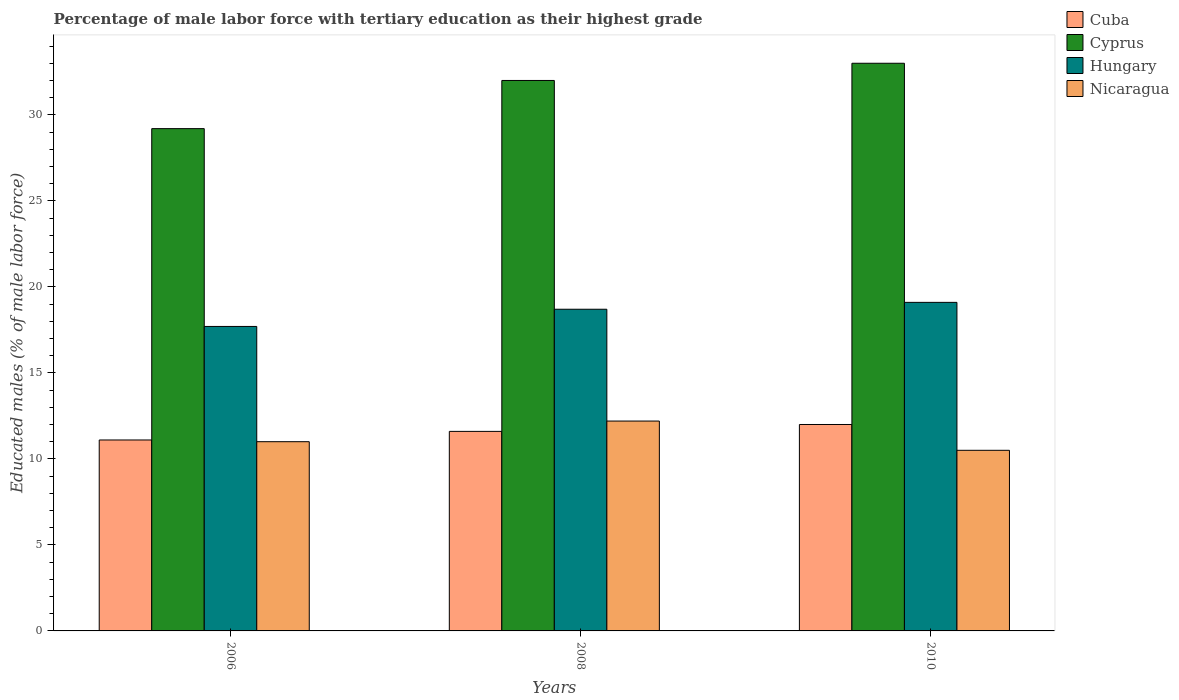Are the number of bars per tick equal to the number of legend labels?
Ensure brevity in your answer.  Yes. Are the number of bars on each tick of the X-axis equal?
Offer a terse response. Yes. How many bars are there on the 2nd tick from the right?
Your answer should be very brief. 4. Across all years, what is the maximum percentage of male labor force with tertiary education in Nicaragua?
Your answer should be very brief. 12.2. Across all years, what is the minimum percentage of male labor force with tertiary education in Cyprus?
Provide a succinct answer. 29.2. In which year was the percentage of male labor force with tertiary education in Cyprus maximum?
Your response must be concise. 2010. What is the total percentage of male labor force with tertiary education in Cuba in the graph?
Provide a succinct answer. 34.7. What is the difference between the percentage of male labor force with tertiary education in Cyprus in 2006 and that in 2008?
Offer a terse response. -2.8. What is the difference between the percentage of male labor force with tertiary education in Nicaragua in 2010 and the percentage of male labor force with tertiary education in Cuba in 2006?
Provide a succinct answer. -0.6. What is the average percentage of male labor force with tertiary education in Cyprus per year?
Your answer should be compact. 31.4. In the year 2010, what is the difference between the percentage of male labor force with tertiary education in Hungary and percentage of male labor force with tertiary education in Cyprus?
Make the answer very short. -13.9. What is the ratio of the percentage of male labor force with tertiary education in Hungary in 2006 to that in 2008?
Give a very brief answer. 0.95. Is the percentage of male labor force with tertiary education in Cyprus in 2008 less than that in 2010?
Provide a succinct answer. Yes. What is the difference between the highest and the second highest percentage of male labor force with tertiary education in Nicaragua?
Ensure brevity in your answer.  1.2. What is the difference between the highest and the lowest percentage of male labor force with tertiary education in Nicaragua?
Provide a succinct answer. 1.7. Is it the case that in every year, the sum of the percentage of male labor force with tertiary education in Nicaragua and percentage of male labor force with tertiary education in Cyprus is greater than the sum of percentage of male labor force with tertiary education in Hungary and percentage of male labor force with tertiary education in Cuba?
Give a very brief answer. No. What does the 2nd bar from the left in 2008 represents?
Make the answer very short. Cyprus. What does the 1st bar from the right in 2008 represents?
Offer a very short reply. Nicaragua. Is it the case that in every year, the sum of the percentage of male labor force with tertiary education in Cyprus and percentage of male labor force with tertiary education in Hungary is greater than the percentage of male labor force with tertiary education in Nicaragua?
Offer a terse response. Yes. What is the difference between two consecutive major ticks on the Y-axis?
Ensure brevity in your answer.  5. Are the values on the major ticks of Y-axis written in scientific E-notation?
Keep it short and to the point. No. Does the graph contain any zero values?
Provide a short and direct response. No. Does the graph contain grids?
Your answer should be compact. No. Where does the legend appear in the graph?
Offer a terse response. Top right. How many legend labels are there?
Keep it short and to the point. 4. What is the title of the graph?
Your answer should be compact. Percentage of male labor force with tertiary education as their highest grade. Does "Montenegro" appear as one of the legend labels in the graph?
Offer a very short reply. No. What is the label or title of the X-axis?
Offer a very short reply. Years. What is the label or title of the Y-axis?
Offer a terse response. Educated males (% of male labor force). What is the Educated males (% of male labor force) in Cuba in 2006?
Keep it short and to the point. 11.1. What is the Educated males (% of male labor force) of Cyprus in 2006?
Give a very brief answer. 29.2. What is the Educated males (% of male labor force) in Hungary in 2006?
Your response must be concise. 17.7. What is the Educated males (% of male labor force) in Nicaragua in 2006?
Offer a terse response. 11. What is the Educated males (% of male labor force) of Cuba in 2008?
Your response must be concise. 11.6. What is the Educated males (% of male labor force) in Cyprus in 2008?
Your answer should be very brief. 32. What is the Educated males (% of male labor force) in Hungary in 2008?
Ensure brevity in your answer.  18.7. What is the Educated males (% of male labor force) in Nicaragua in 2008?
Ensure brevity in your answer.  12.2. What is the Educated males (% of male labor force) in Cuba in 2010?
Provide a short and direct response. 12. What is the Educated males (% of male labor force) of Hungary in 2010?
Ensure brevity in your answer.  19.1. What is the Educated males (% of male labor force) of Nicaragua in 2010?
Your response must be concise. 10.5. Across all years, what is the maximum Educated males (% of male labor force) in Cyprus?
Offer a terse response. 33. Across all years, what is the maximum Educated males (% of male labor force) in Hungary?
Give a very brief answer. 19.1. Across all years, what is the maximum Educated males (% of male labor force) of Nicaragua?
Keep it short and to the point. 12.2. Across all years, what is the minimum Educated males (% of male labor force) in Cuba?
Your answer should be compact. 11.1. Across all years, what is the minimum Educated males (% of male labor force) of Cyprus?
Offer a terse response. 29.2. Across all years, what is the minimum Educated males (% of male labor force) of Hungary?
Your response must be concise. 17.7. What is the total Educated males (% of male labor force) in Cuba in the graph?
Provide a succinct answer. 34.7. What is the total Educated males (% of male labor force) in Cyprus in the graph?
Give a very brief answer. 94.2. What is the total Educated males (% of male labor force) of Hungary in the graph?
Offer a very short reply. 55.5. What is the total Educated males (% of male labor force) in Nicaragua in the graph?
Offer a very short reply. 33.7. What is the difference between the Educated males (% of male labor force) in Cyprus in 2006 and that in 2010?
Give a very brief answer. -3.8. What is the difference between the Educated males (% of male labor force) in Nicaragua in 2006 and that in 2010?
Your response must be concise. 0.5. What is the difference between the Educated males (% of male labor force) in Cuba in 2008 and that in 2010?
Offer a very short reply. -0.4. What is the difference between the Educated males (% of male labor force) of Cyprus in 2008 and that in 2010?
Make the answer very short. -1. What is the difference between the Educated males (% of male labor force) of Hungary in 2008 and that in 2010?
Keep it short and to the point. -0.4. What is the difference between the Educated males (% of male labor force) in Nicaragua in 2008 and that in 2010?
Your answer should be very brief. 1.7. What is the difference between the Educated males (% of male labor force) of Cuba in 2006 and the Educated males (% of male labor force) of Cyprus in 2008?
Provide a succinct answer. -20.9. What is the difference between the Educated males (% of male labor force) of Cuba in 2006 and the Educated males (% of male labor force) of Hungary in 2008?
Your answer should be compact. -7.6. What is the difference between the Educated males (% of male labor force) in Cyprus in 2006 and the Educated males (% of male labor force) in Nicaragua in 2008?
Offer a very short reply. 17. What is the difference between the Educated males (% of male labor force) in Hungary in 2006 and the Educated males (% of male labor force) in Nicaragua in 2008?
Your answer should be very brief. 5.5. What is the difference between the Educated males (% of male labor force) of Cuba in 2006 and the Educated males (% of male labor force) of Cyprus in 2010?
Make the answer very short. -21.9. What is the difference between the Educated males (% of male labor force) of Hungary in 2006 and the Educated males (% of male labor force) of Nicaragua in 2010?
Your answer should be very brief. 7.2. What is the difference between the Educated males (% of male labor force) of Cuba in 2008 and the Educated males (% of male labor force) of Cyprus in 2010?
Your answer should be very brief. -21.4. What is the difference between the Educated males (% of male labor force) of Cuba in 2008 and the Educated males (% of male labor force) of Nicaragua in 2010?
Your answer should be very brief. 1.1. What is the difference between the Educated males (% of male labor force) of Cyprus in 2008 and the Educated males (% of male labor force) of Hungary in 2010?
Your answer should be compact. 12.9. What is the difference between the Educated males (% of male labor force) in Cyprus in 2008 and the Educated males (% of male labor force) in Nicaragua in 2010?
Make the answer very short. 21.5. What is the average Educated males (% of male labor force) of Cuba per year?
Keep it short and to the point. 11.57. What is the average Educated males (% of male labor force) of Cyprus per year?
Keep it short and to the point. 31.4. What is the average Educated males (% of male labor force) of Nicaragua per year?
Ensure brevity in your answer.  11.23. In the year 2006, what is the difference between the Educated males (% of male labor force) of Cuba and Educated males (% of male labor force) of Cyprus?
Your answer should be compact. -18.1. In the year 2006, what is the difference between the Educated males (% of male labor force) in Cuba and Educated males (% of male labor force) in Hungary?
Ensure brevity in your answer.  -6.6. In the year 2006, what is the difference between the Educated males (% of male labor force) of Cuba and Educated males (% of male labor force) of Nicaragua?
Provide a succinct answer. 0.1. In the year 2006, what is the difference between the Educated males (% of male labor force) of Cyprus and Educated males (% of male labor force) of Hungary?
Provide a short and direct response. 11.5. In the year 2006, what is the difference between the Educated males (% of male labor force) of Cyprus and Educated males (% of male labor force) of Nicaragua?
Your answer should be compact. 18.2. In the year 2008, what is the difference between the Educated males (% of male labor force) in Cuba and Educated males (% of male labor force) in Cyprus?
Provide a short and direct response. -20.4. In the year 2008, what is the difference between the Educated males (% of male labor force) of Cyprus and Educated males (% of male labor force) of Hungary?
Make the answer very short. 13.3. In the year 2008, what is the difference between the Educated males (% of male labor force) of Cyprus and Educated males (% of male labor force) of Nicaragua?
Offer a very short reply. 19.8. In the year 2008, what is the difference between the Educated males (% of male labor force) in Hungary and Educated males (% of male labor force) in Nicaragua?
Ensure brevity in your answer.  6.5. In the year 2010, what is the difference between the Educated males (% of male labor force) of Cuba and Educated males (% of male labor force) of Cyprus?
Your answer should be compact. -21. In the year 2010, what is the difference between the Educated males (% of male labor force) in Cyprus and Educated males (% of male labor force) in Nicaragua?
Give a very brief answer. 22.5. What is the ratio of the Educated males (% of male labor force) in Cuba in 2006 to that in 2008?
Keep it short and to the point. 0.96. What is the ratio of the Educated males (% of male labor force) of Cyprus in 2006 to that in 2008?
Your answer should be compact. 0.91. What is the ratio of the Educated males (% of male labor force) of Hungary in 2006 to that in 2008?
Your response must be concise. 0.95. What is the ratio of the Educated males (% of male labor force) of Nicaragua in 2006 to that in 2008?
Your answer should be compact. 0.9. What is the ratio of the Educated males (% of male labor force) of Cuba in 2006 to that in 2010?
Your answer should be compact. 0.93. What is the ratio of the Educated males (% of male labor force) of Cyprus in 2006 to that in 2010?
Your answer should be compact. 0.88. What is the ratio of the Educated males (% of male labor force) in Hungary in 2006 to that in 2010?
Your answer should be compact. 0.93. What is the ratio of the Educated males (% of male labor force) in Nicaragua in 2006 to that in 2010?
Provide a succinct answer. 1.05. What is the ratio of the Educated males (% of male labor force) of Cuba in 2008 to that in 2010?
Ensure brevity in your answer.  0.97. What is the ratio of the Educated males (% of male labor force) in Cyprus in 2008 to that in 2010?
Your answer should be very brief. 0.97. What is the ratio of the Educated males (% of male labor force) in Hungary in 2008 to that in 2010?
Give a very brief answer. 0.98. What is the ratio of the Educated males (% of male labor force) of Nicaragua in 2008 to that in 2010?
Keep it short and to the point. 1.16. What is the difference between the highest and the second highest Educated males (% of male labor force) in Nicaragua?
Offer a very short reply. 1.2. What is the difference between the highest and the lowest Educated males (% of male labor force) in Cuba?
Your answer should be very brief. 0.9. What is the difference between the highest and the lowest Educated males (% of male labor force) in Cyprus?
Provide a short and direct response. 3.8. 